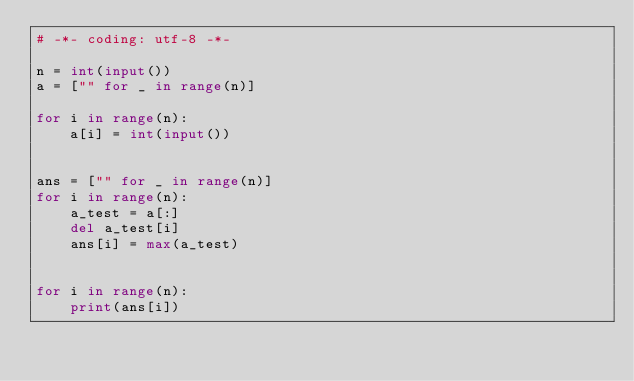Convert code to text. <code><loc_0><loc_0><loc_500><loc_500><_Python_># -*- coding: utf-8 -*-

n = int(input())
a = ["" for _ in range(n)]

for i in range(n):
    a[i] = int(input())


ans = ["" for _ in range(n)]
for i in range(n):
    a_test = a[:]
    del a_test[i]
    ans[i] = max(a_test)


for i in range(n):
    print(ans[i])
</code> 